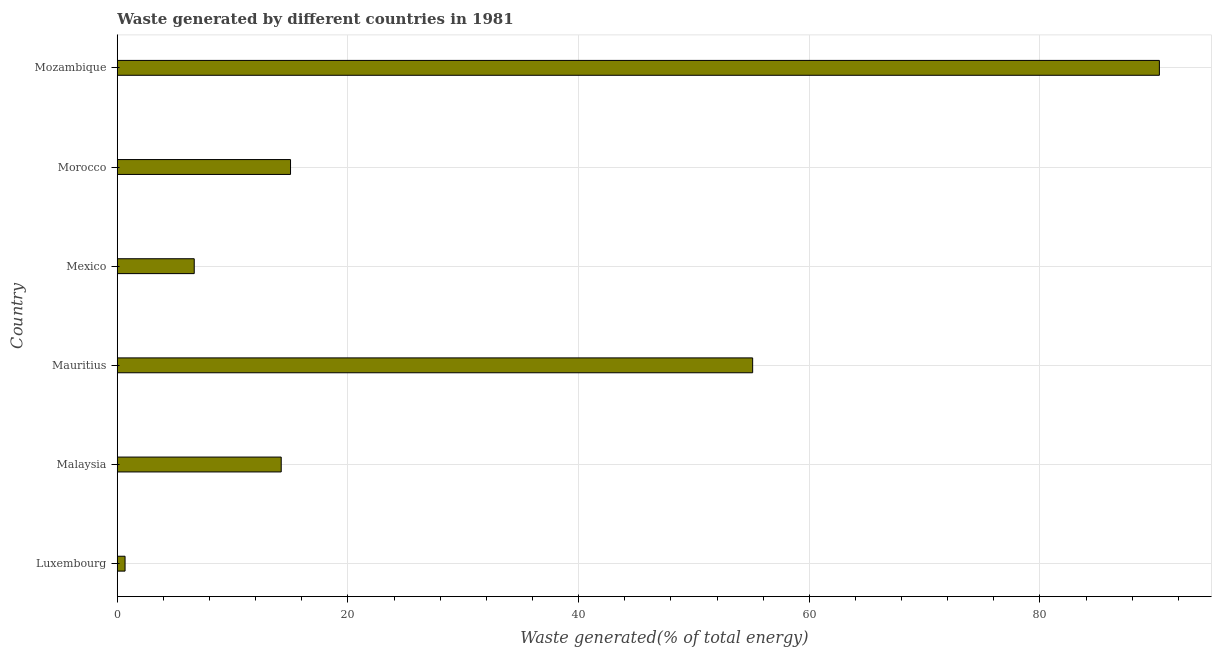Does the graph contain grids?
Offer a very short reply. Yes. What is the title of the graph?
Offer a terse response. Waste generated by different countries in 1981. What is the label or title of the X-axis?
Ensure brevity in your answer.  Waste generated(% of total energy). What is the label or title of the Y-axis?
Offer a terse response. Country. What is the amount of waste generated in Mauritius?
Your answer should be very brief. 55.09. Across all countries, what is the maximum amount of waste generated?
Make the answer very short. 90.36. Across all countries, what is the minimum amount of waste generated?
Your response must be concise. 0.67. In which country was the amount of waste generated maximum?
Provide a succinct answer. Mozambique. In which country was the amount of waste generated minimum?
Your answer should be very brief. Luxembourg. What is the sum of the amount of waste generated?
Your answer should be compact. 182.03. What is the difference between the amount of waste generated in Malaysia and Mauritius?
Give a very brief answer. -40.88. What is the average amount of waste generated per country?
Give a very brief answer. 30.34. What is the median amount of waste generated?
Your answer should be very brief. 14.62. In how many countries, is the amount of waste generated greater than 28 %?
Ensure brevity in your answer.  2. What is the ratio of the amount of waste generated in Mauritius to that in Morocco?
Give a very brief answer. 3.67. Is the amount of waste generated in Mexico less than that in Morocco?
Offer a very short reply. Yes. What is the difference between the highest and the second highest amount of waste generated?
Provide a succinct answer. 35.27. Is the sum of the amount of waste generated in Luxembourg and Mauritius greater than the maximum amount of waste generated across all countries?
Your response must be concise. No. What is the difference between the highest and the lowest amount of waste generated?
Ensure brevity in your answer.  89.69. How many bars are there?
Provide a succinct answer. 6. Are all the bars in the graph horizontal?
Give a very brief answer. Yes. How many countries are there in the graph?
Make the answer very short. 6. What is the difference between two consecutive major ticks on the X-axis?
Make the answer very short. 20. What is the Waste generated(% of total energy) in Luxembourg?
Your answer should be compact. 0.67. What is the Waste generated(% of total energy) in Malaysia?
Keep it short and to the point. 14.21. What is the Waste generated(% of total energy) of Mauritius?
Keep it short and to the point. 55.09. What is the Waste generated(% of total energy) in Mexico?
Your answer should be very brief. 6.67. What is the Waste generated(% of total energy) in Morocco?
Offer a very short reply. 15.02. What is the Waste generated(% of total energy) of Mozambique?
Provide a succinct answer. 90.36. What is the difference between the Waste generated(% of total energy) in Luxembourg and Malaysia?
Give a very brief answer. -13.54. What is the difference between the Waste generated(% of total energy) in Luxembourg and Mauritius?
Keep it short and to the point. -54.42. What is the difference between the Waste generated(% of total energy) in Luxembourg and Mexico?
Provide a short and direct response. -6. What is the difference between the Waste generated(% of total energy) in Luxembourg and Morocco?
Provide a short and direct response. -14.35. What is the difference between the Waste generated(% of total energy) in Luxembourg and Mozambique?
Your response must be concise. -89.69. What is the difference between the Waste generated(% of total energy) in Malaysia and Mauritius?
Ensure brevity in your answer.  -40.88. What is the difference between the Waste generated(% of total energy) in Malaysia and Mexico?
Your answer should be compact. 7.54. What is the difference between the Waste generated(% of total energy) in Malaysia and Morocco?
Your answer should be compact. -0.81. What is the difference between the Waste generated(% of total energy) in Malaysia and Mozambique?
Your answer should be very brief. -76.14. What is the difference between the Waste generated(% of total energy) in Mauritius and Mexico?
Offer a terse response. 48.42. What is the difference between the Waste generated(% of total energy) in Mauritius and Morocco?
Your answer should be compact. 40.07. What is the difference between the Waste generated(% of total energy) in Mauritius and Mozambique?
Your answer should be compact. -35.27. What is the difference between the Waste generated(% of total energy) in Mexico and Morocco?
Make the answer very short. -8.35. What is the difference between the Waste generated(% of total energy) in Mexico and Mozambique?
Provide a short and direct response. -83.69. What is the difference between the Waste generated(% of total energy) in Morocco and Mozambique?
Offer a terse response. -75.34. What is the ratio of the Waste generated(% of total energy) in Luxembourg to that in Malaysia?
Give a very brief answer. 0.05. What is the ratio of the Waste generated(% of total energy) in Luxembourg to that in Mauritius?
Keep it short and to the point. 0.01. What is the ratio of the Waste generated(% of total energy) in Luxembourg to that in Mexico?
Provide a short and direct response. 0.1. What is the ratio of the Waste generated(% of total energy) in Luxembourg to that in Morocco?
Keep it short and to the point. 0.04. What is the ratio of the Waste generated(% of total energy) in Luxembourg to that in Mozambique?
Offer a terse response. 0.01. What is the ratio of the Waste generated(% of total energy) in Malaysia to that in Mauritius?
Your response must be concise. 0.26. What is the ratio of the Waste generated(% of total energy) in Malaysia to that in Mexico?
Keep it short and to the point. 2.13. What is the ratio of the Waste generated(% of total energy) in Malaysia to that in Morocco?
Make the answer very short. 0.95. What is the ratio of the Waste generated(% of total energy) in Malaysia to that in Mozambique?
Your answer should be very brief. 0.16. What is the ratio of the Waste generated(% of total energy) in Mauritius to that in Mexico?
Offer a very short reply. 8.26. What is the ratio of the Waste generated(% of total energy) in Mauritius to that in Morocco?
Offer a very short reply. 3.67. What is the ratio of the Waste generated(% of total energy) in Mauritius to that in Mozambique?
Make the answer very short. 0.61. What is the ratio of the Waste generated(% of total energy) in Mexico to that in Morocco?
Give a very brief answer. 0.44. What is the ratio of the Waste generated(% of total energy) in Mexico to that in Mozambique?
Provide a succinct answer. 0.07. What is the ratio of the Waste generated(% of total energy) in Morocco to that in Mozambique?
Your answer should be very brief. 0.17. 